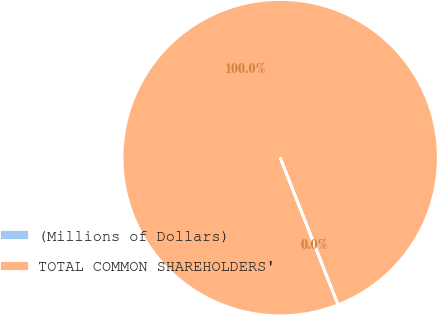<chart> <loc_0><loc_0><loc_500><loc_500><pie_chart><fcel>(Millions of Dollars)<fcel>TOTAL COMMON SHAREHOLDERS'<nl><fcel>0.0%<fcel>100.0%<nl></chart> 